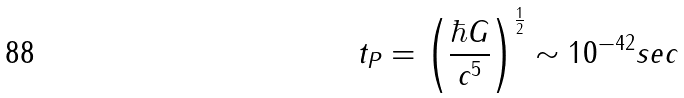<formula> <loc_0><loc_0><loc_500><loc_500>t _ { P } = \left ( \frac { \hbar { G } } { c ^ { 5 } } \right ) ^ { \frac { 1 } { 2 } } \sim 1 0 ^ { - 4 2 } s e c</formula> 